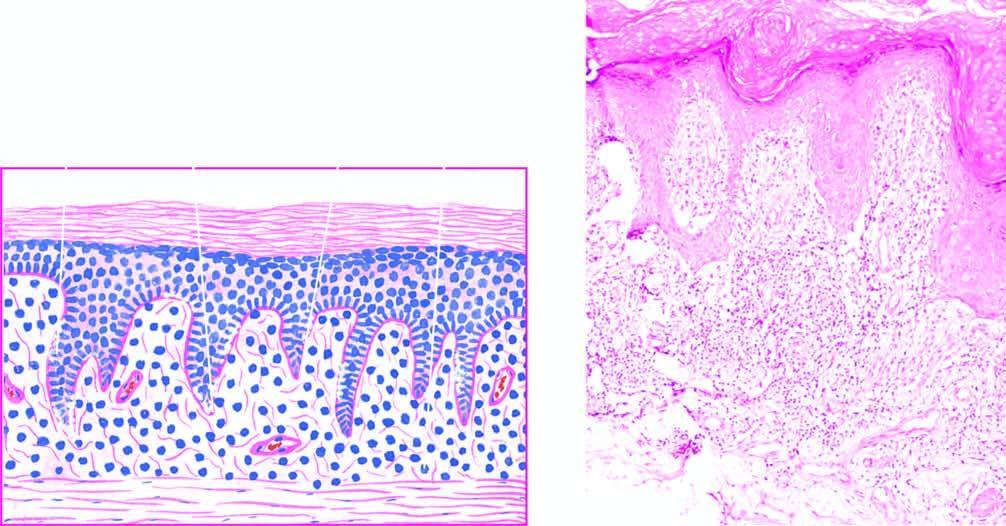what is there with elongated saw-toothed rete ridges?
Answer the question using a single word or phrase. Hyperkeratosis 